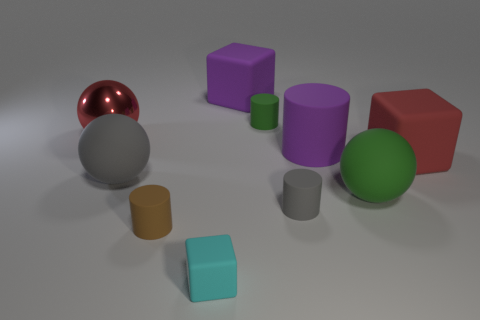Is the color of the big rubber block that is on the right side of the tiny green cylinder the same as the big shiny thing?
Offer a terse response. Yes. The small block that is made of the same material as the big gray ball is what color?
Provide a succinct answer. Cyan. Do the brown rubber thing and the metallic ball have the same size?
Ensure brevity in your answer.  No. What is the brown cylinder made of?
Provide a short and direct response. Rubber. What is the material of the gray object that is the same size as the red sphere?
Offer a very short reply. Rubber. Is there a green ball of the same size as the gray ball?
Offer a terse response. Yes. Is the number of objects that are left of the gray cylinder the same as the number of red metal objects that are to the right of the large green thing?
Give a very brief answer. No. Are there more yellow matte cubes than tiny cylinders?
Your response must be concise. No. What number of matte things are either purple things or green spheres?
Ensure brevity in your answer.  3. What number of big blocks have the same color as the big matte cylinder?
Give a very brief answer. 1. 